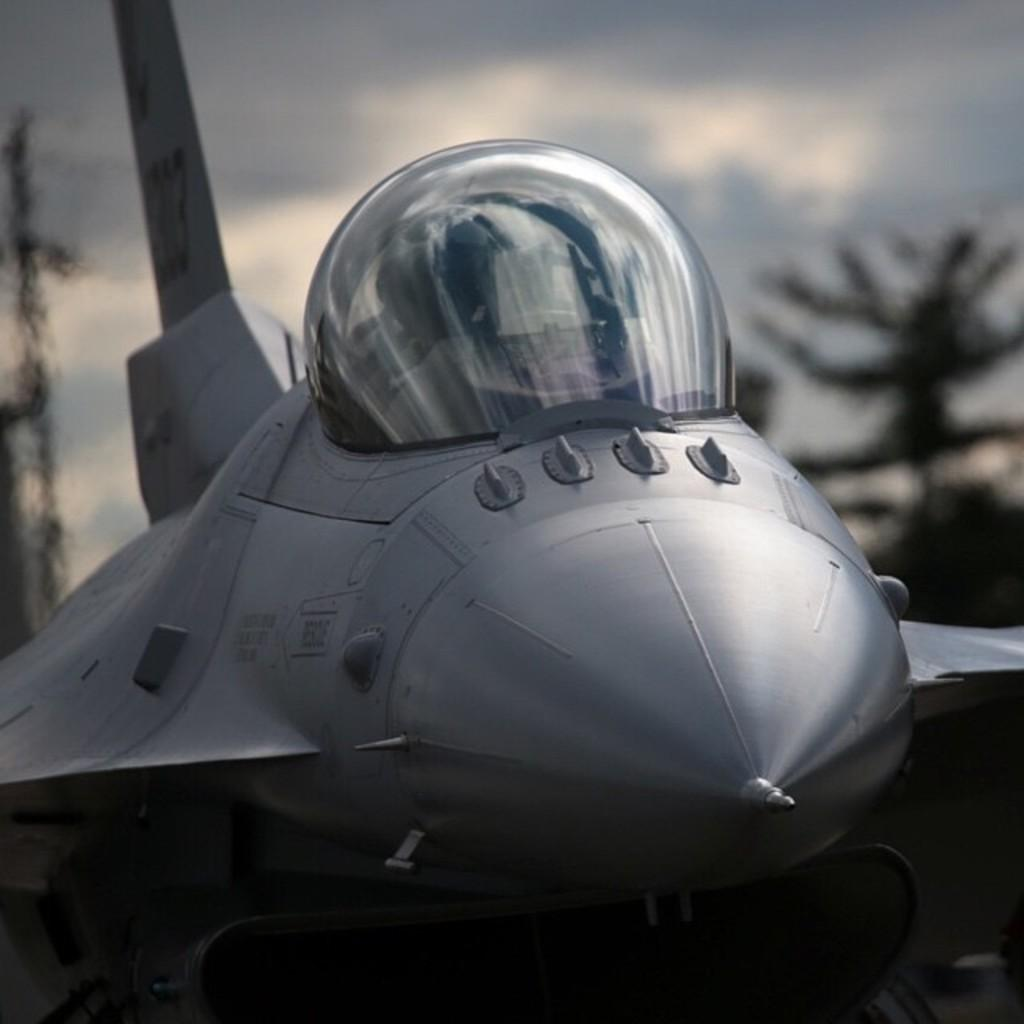What is the main subject of the picture? The main subject of the picture is an aircraft. Can you describe the background of the image? The background of the image is blurred. What can be seen in the background of the image? There are trees in the background of the image. How would you describe the weather in the image? The sky is cloudy in the image. How many eyes can be seen on the aircraft in the image? There are no eyes visible on the aircraft in the image, as it is not a living being. What type of watch is the aircraft wearing in the image? There is no watch present in the image, as it is not a living being capable of wearing accessories. 